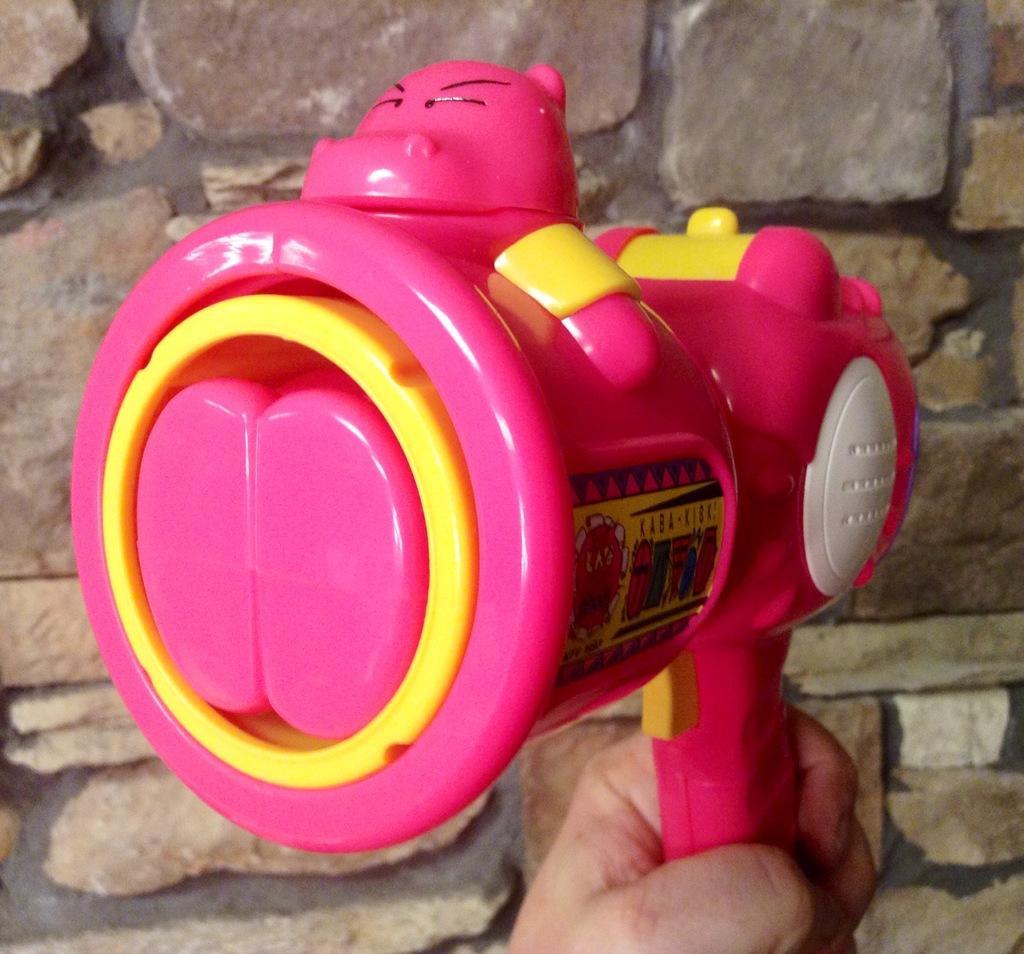How would you summarize this image in a sentence or two? In this image we can see a toy which is of pink and yellow color which is held by a person's hand and at the background of the image there is wall. 